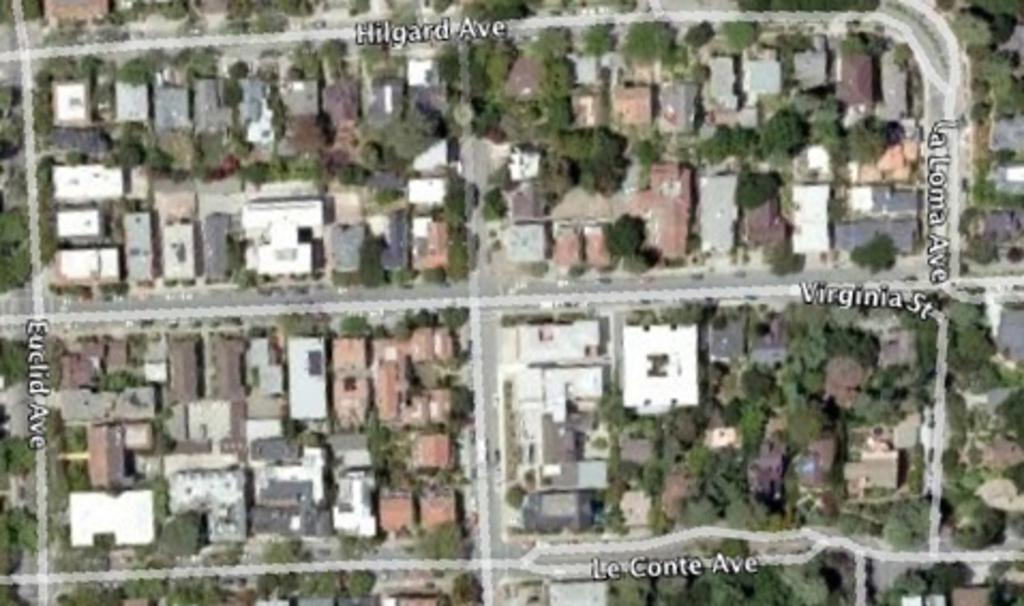What type of image is being described? The image is a Google image. What can be seen on the ground in the image? There is a road visible in the image. What type of natural elements are present in the image? There are trees in the image. What type of man-made structures are present in the image? There are buildings in the image. What other objects can be seen in the image? There are other objects in the image. Is there a rainstorm happening in the image? There is no indication of a rainstorm in the image; it appears to be a clear day. Can the buildings in the image be controlled remotely? There is no information about the buildings being controlled remotely in the image. 